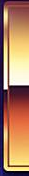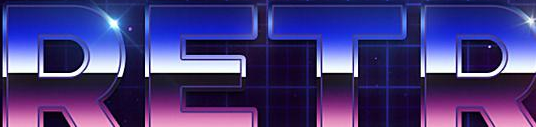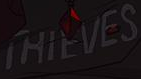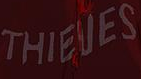Transcribe the words shown in these images in order, separated by a semicolon. #; RETR; THIEVES; THIEVES 